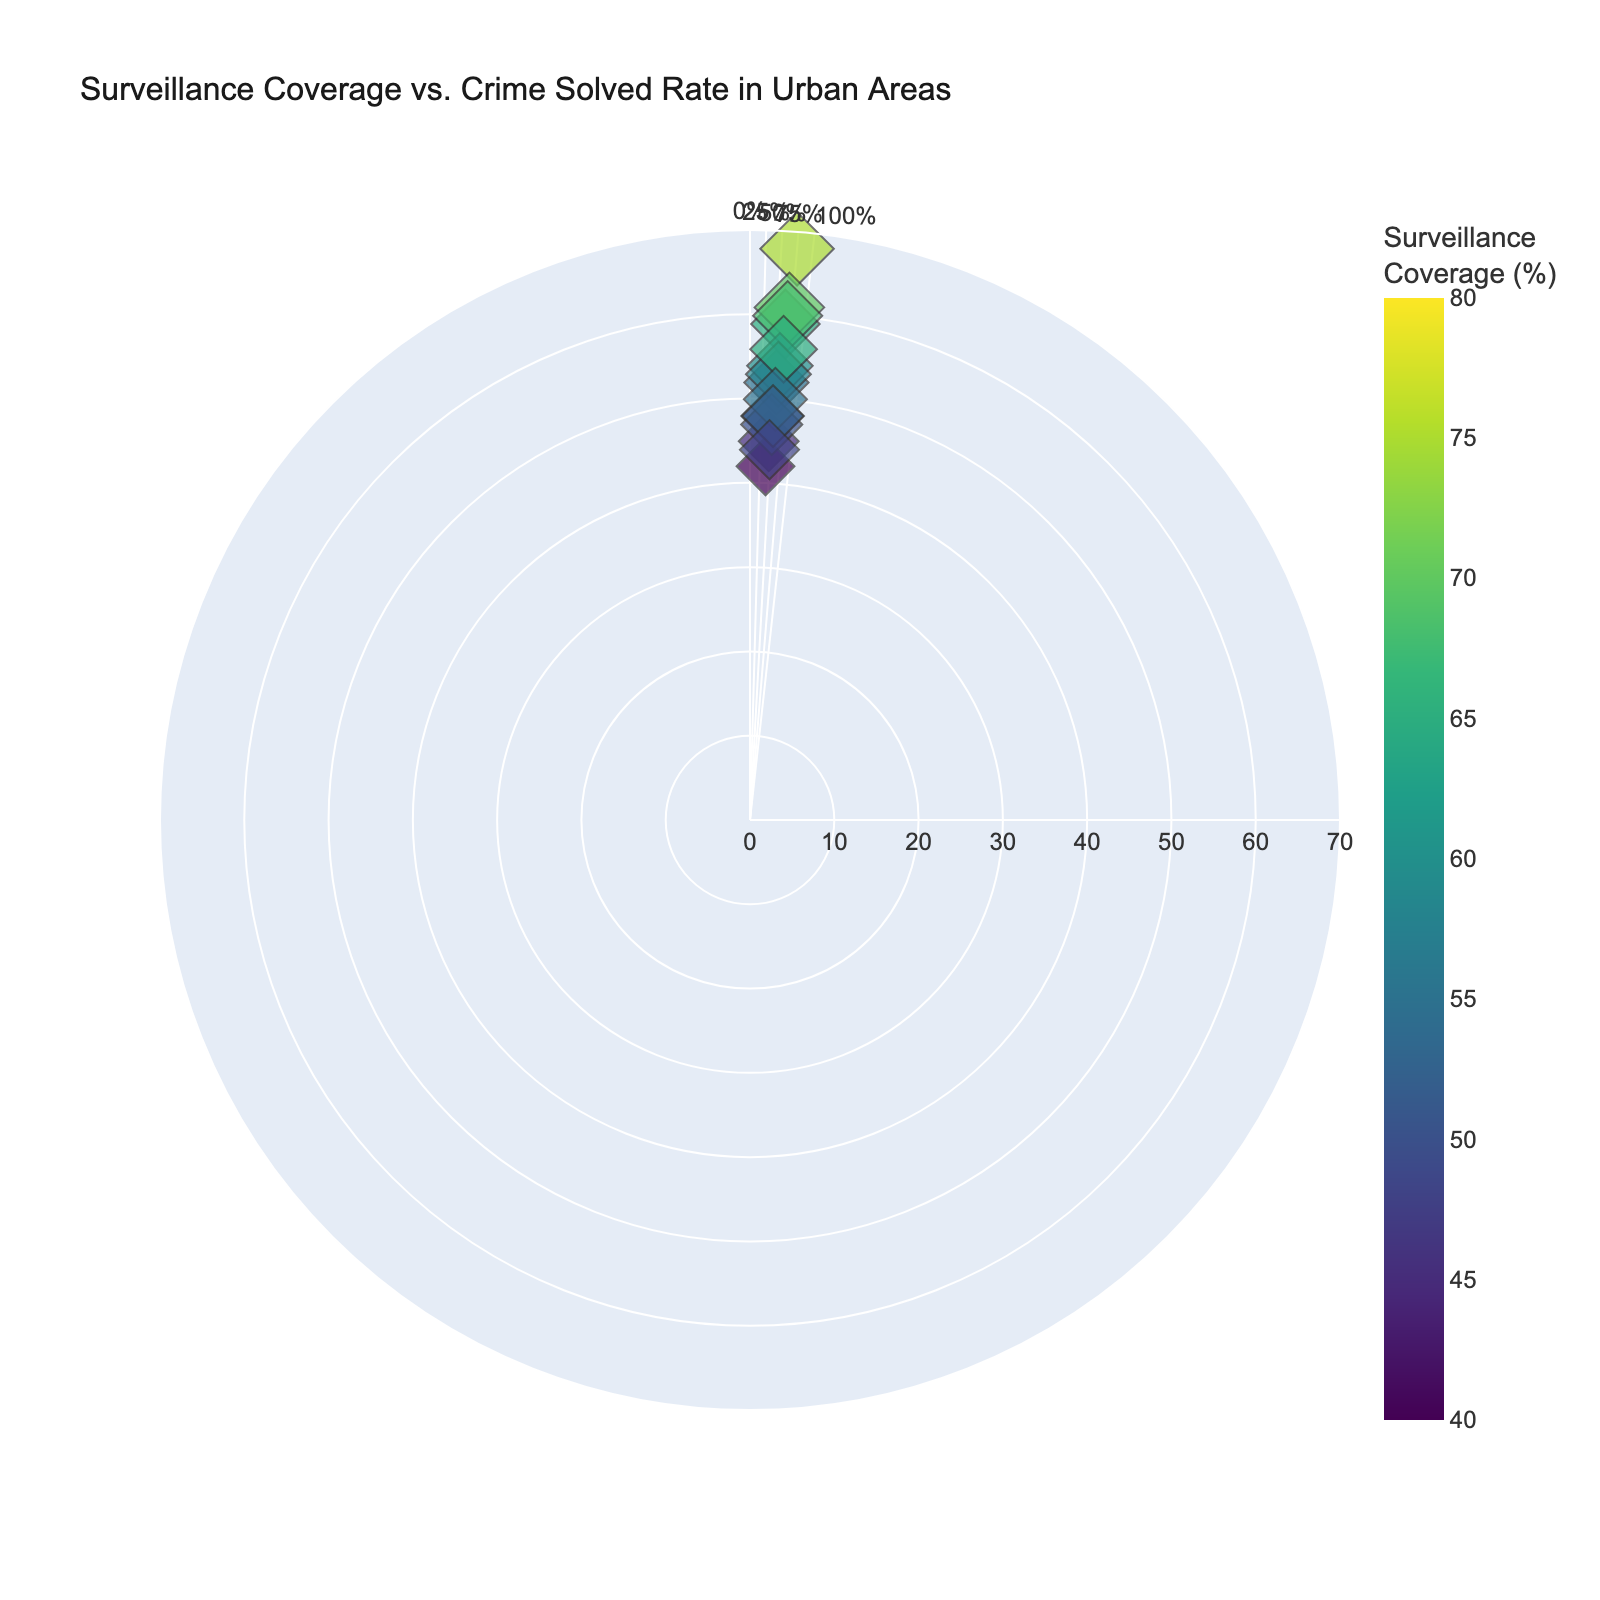How many cities are represented in the plot? Count the number of distinct data points or names in the hover information to determine how many cities are plotted.
Answer: 15 What is the city with the highest surveillance coverage and what is its crime solved rate? Look for the data point with the highest color intensity on the chart and hover over it to identify the city and its corresponding crime solved rate.
Answer: New York City, 68% Which city has the lowest crime solved rate, and what is its surveillance coverage percentage? Find the data point closest to the center of the polar chart and hover over it to see the city and its coverage percentage.
Answer: Austin, 40% How does the crime solved rate in Houston compare with that in San Diego? Compare the radial distance (crime solved rate percentage) of Houston and San Diego's data points from the center of the chart to see which city has a higher rate.
Answer: Houston has a lower crime solved rate (52% vs. 54%) Which cities have a surveillance coverage percentage between 50 and 60%? Look for data points within the 50-60% angular range and hover over them to identify the cities.
Answer: Houston, San Diego, Dallas, Fort Worth, Columbus Is there a city with a 45% crime solved rate and what is its surveillance coverage? Find the data point at the 45% radial distance from the center and hover over it to see the city and its surveillance coverage.
Answer: Phoenix, 45% Calculate the average crime solved rate for cities with surveillance coverage greater than 60%. Identify cities with surveillance coverage above 60% (New York City, Los Angeles, Chicago, Philadelphia, San Jose) and calculate their average crime solved rate. (68+59+61+60+56)/5 = 60.8
Answer: 60.8% For cities with less than 50% surveillance coverage, which one has the highest crime solved rate? Look for data points with less than 50% surveillance coverage and compare their radial distances to find the city with the highest rate.
Answer: Jacksonville Compare the surveillance coverage of Philadelphia and San Antonio. Which city has higher coverage? Compare the angular position of Philadelphia and San Antonio's data points to see which one is farther from 0% on the chart.
Answer: Philadelphia Does higher surveillance coverage always correlate with higher crime solved rates? Analyze the overall trend by observing the distribution of data points’ radial distances relative to their angular positions (coverage percentages) to determine if there is a consistent upward trend.
Answer: No 